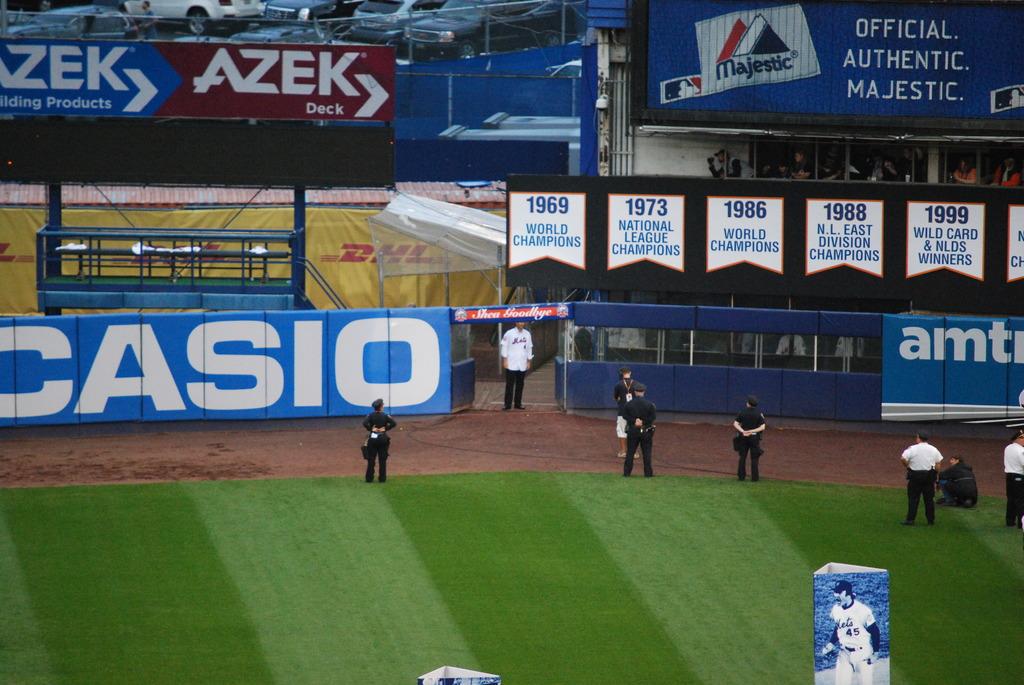What watch maker is on t he outfield wall?
Provide a succinct answer. Casio. 